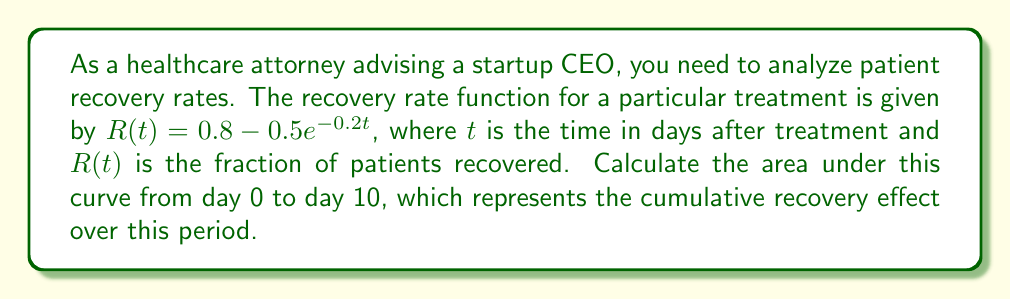Can you answer this question? To find the area under the curve, we need to integrate the function $R(t)$ from $t=0$ to $t=10$. Here's the step-by-step process:

1) Set up the definite integral:
   $$\int_0^{10} (0.8 - 0.5e^{-0.2t}) dt$$

2) Split the integral:
   $$\int_0^{10} 0.8 dt - \int_0^{10} 0.5e^{-0.2t} dt$$

3) Evaluate the first part:
   $$0.8t \bigg|_0^{10} - \int_0^{10} 0.5e^{-0.2t} dt$$
   $$= 8 - \int_0^{10} 0.5e^{-0.2t} dt$$

4) For the second part, use u-substitution:
   Let $u = -0.2t$, then $du = -0.2dt$ or $dt = -5du$
   When $t=0$, $u=0$; when $t=10$, $u=-2$

   $$= 8 - (-5)(0.5)\int_0^{-2} e^u du$$
   $$= 8 + 2.5[e^u]_0^{-2}$$
   $$= 8 + 2.5(e^{-2} - e^0)$$
   $$= 8 + 2.5(e^{-2} - 1)$$

5) Calculate the final result:
   $$= 8 + 2.5(0.1353 - 1)$$
   $$= 8 - 2.16175$$
   $$= 5.83825$$
Answer: $5.83825$ 